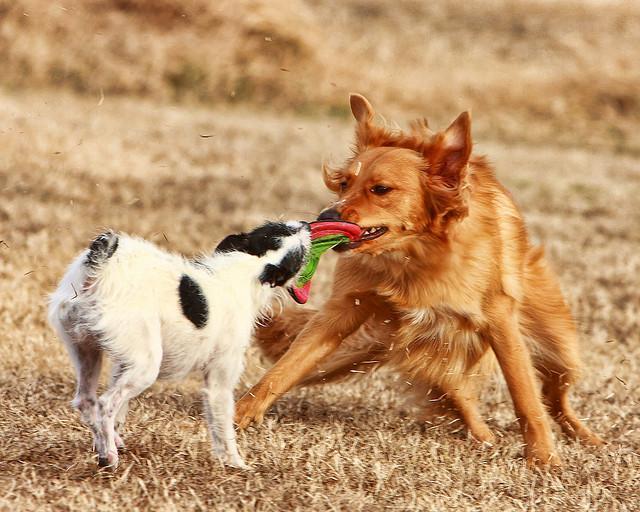How many dogs are there?
Give a very brief answer. 2. 